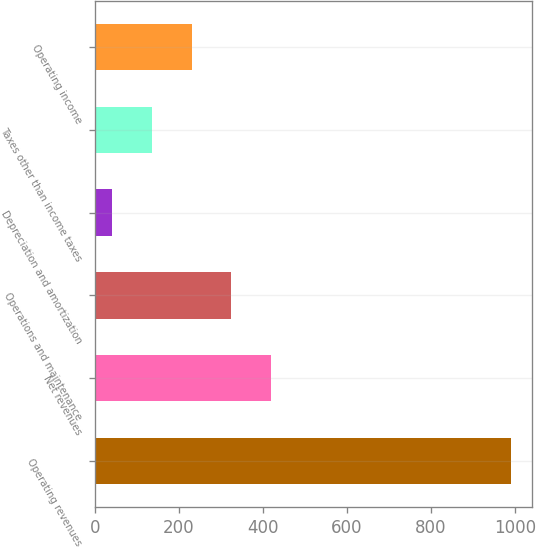Convert chart. <chart><loc_0><loc_0><loc_500><loc_500><bar_chart><fcel>Operating revenues<fcel>Net revenues<fcel>Operations and maintenance<fcel>Depreciation and amortization<fcel>Taxes other than income taxes<fcel>Operating income<nl><fcel>991<fcel>420.4<fcel>325.3<fcel>40<fcel>135.1<fcel>230.2<nl></chart> 